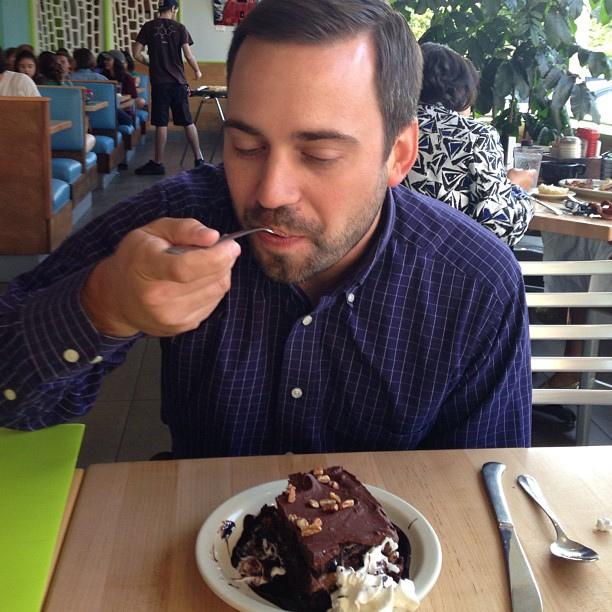Is this man in his home?
Write a very short answer. No. What food is crumbled on top of the desert?
Quick response, please. Nuts. What utensils are on the table?
Concise answer only. Knife and spoon. What is the guy doing?
Answer briefly. Eating. 